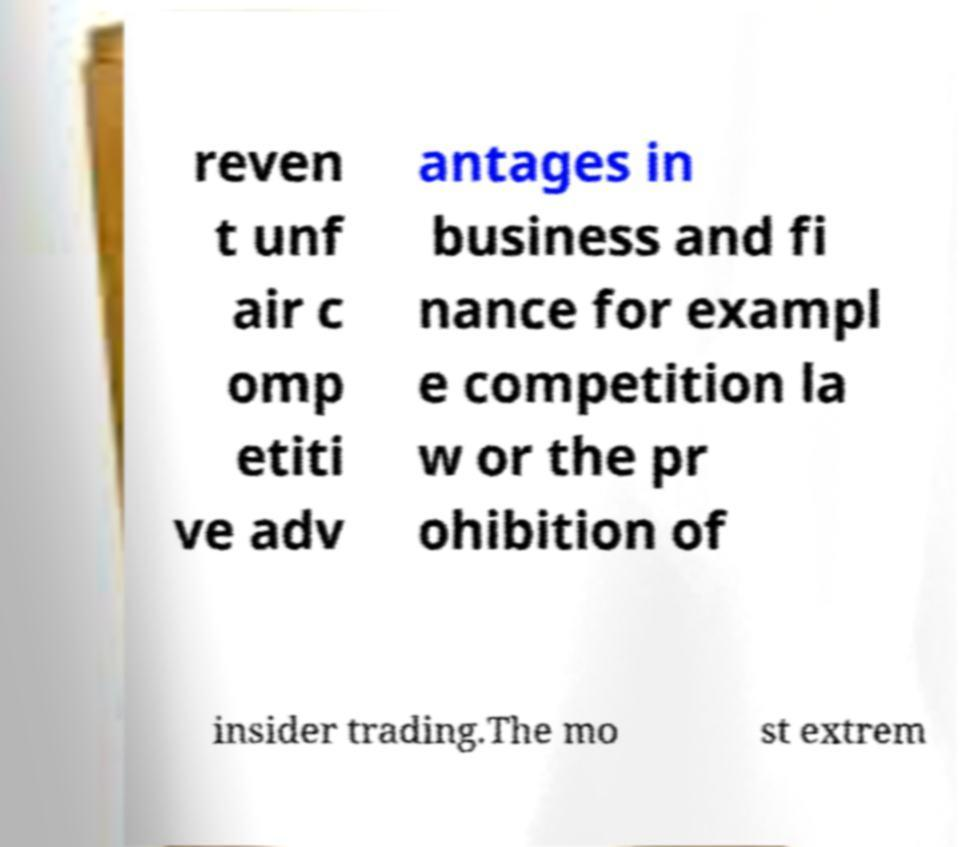Please read and relay the text visible in this image. What does it say? reven t unf air c omp etiti ve adv antages in business and fi nance for exampl e competition la w or the pr ohibition of insider trading.The mo st extrem 